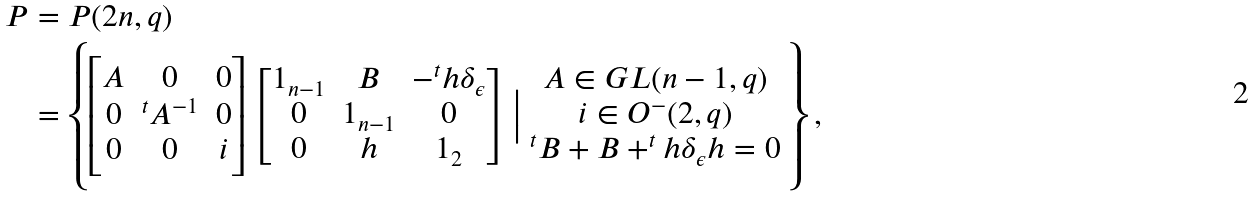Convert formula to latex. <formula><loc_0><loc_0><loc_500><loc_500>P & = P ( 2 n , q ) \\ & = \left \{ \begin{bmatrix} A & 0 & 0 \\ 0 & ^ { t } A ^ { - 1 } & 0 \\ 0 & 0 & i \\ \end{bmatrix} \begin{bmatrix} 1 _ { n - 1 } & B & - ^ { t } h \delta _ { \epsilon } \\ 0 & 1 _ { n - 1 } & 0 \\ 0 & h & 1 _ { 2 } \\ \end{bmatrix} \Big | \begin{array} { c } A \in G L ( n - 1 , q ) \\ i \in O ^ { - } ( 2 , q ) \\ ^ { t } B + B + ^ { t } h \delta _ { \epsilon } h = 0 \end{array} \right \} ,</formula> 